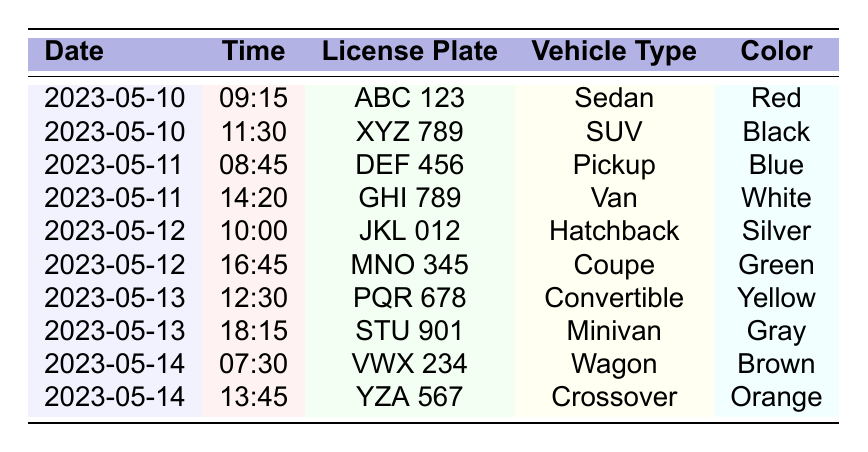What is the license plate of the red sedan? The table lists a red sedan with the license plate ABC 123 on the date 2023-05-10 at 09:15.
Answer: ABC 123 How many vehicles were observed on May 11, 2023? On May 11, the table shows two vehicles: DEF 456 (Pickup) at 08:45 and GHI 789 (Van) at 14:20, totaling two vehicles.
Answer: 2 What color is the vehicle with license plate GHI 789? According to the table, GHI 789 is a white van observed on May 11, 2023, at 14:20.
Answer: White Which vehicle type was observed at 12:30 on May 13, 2023? The table indicates that at 12:30 on May 13, 2023, the vehicle PQR 678 was a convertible.
Answer: Convertible Did a black SUV appear in the observations? Yes, the table confirms that on May 10, 2023, at 11:30, a black SUV with the license plate XYZ 789 was observed.
Answer: Yes What is the total number of vehicles observed over the four days? The table shows a total of 10 observations: 2 on May 10, 2 on May 11, 2 on May 12, 2 on May 13, and 2 on May 14. Therefore, the total is 10.
Answer: 10 Which color was the last vehicle observed? The table lists the last vehicle as a crossover with the license plate YZA 567, which is orange, observed on May 14, 2023, at 13:45.
Answer: Orange How many different vehicle types are listed for May 12, 2023? On May 12, there are two different vehicle types: JKL 012 (Hatchback) and MNO 345 (Coupe).
Answer: 2 Was there a minivan observed on May 13, 2023? Yes, the table shows a minivan with the license plate STU 901 observed at 18:15 on May 13, 2023.
Answer: Yes What is the average time of observation for all vehicles? The times of observations are 09:15, 11:30, 08:45, 14:20, 10:00, 16:45, 12:30, 18:15, 07:30, and 13:45. Converting to minutes since midnight: 555, 690, 525, 860, 600, 1005, 750, 1095, 450, 825. The average is (555 + 690 + 525 + 860 + 600 + 1005 + 750 + 1095 + 450 + 825) / 10 = 718.5 minutes. Converting back to time gives approximately 11:58 AM.
Answer: 11:58 AM 